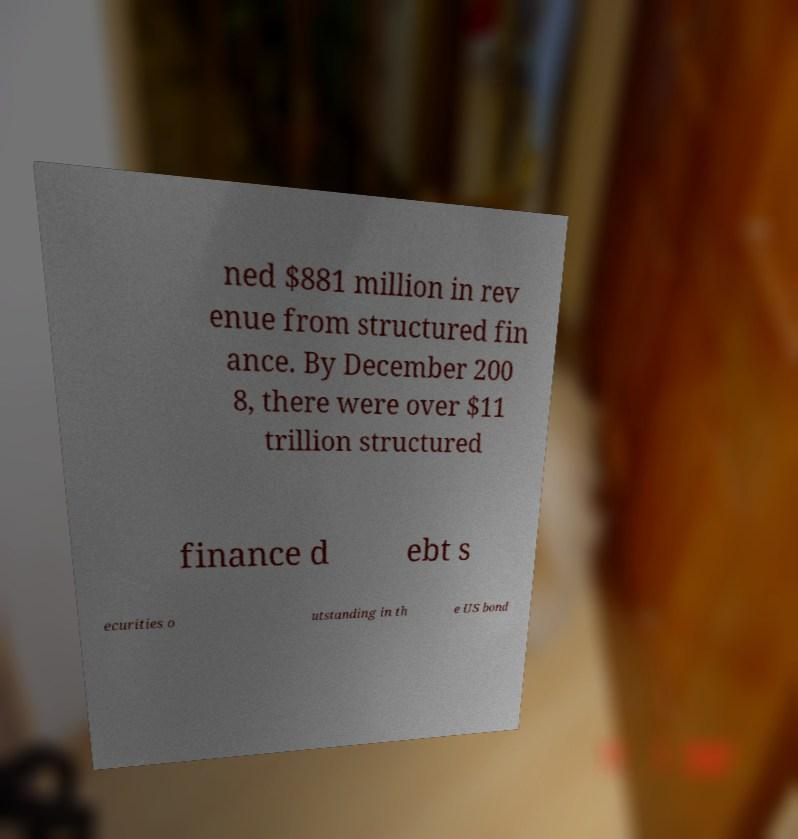What messages or text are displayed in this image? I need them in a readable, typed format. ned $881 million in rev enue from structured fin ance. By December 200 8, there were over $11 trillion structured finance d ebt s ecurities o utstanding in th e US bond 